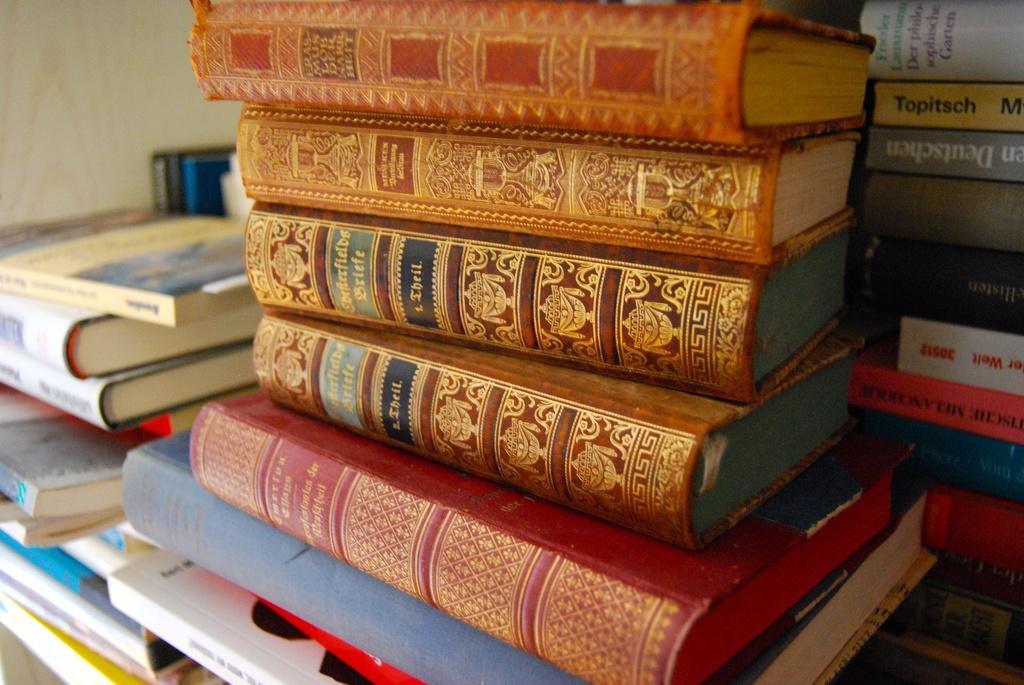In one or two sentences, can you explain what this image depicts? In this image there are so many books one upon the other on an object. 